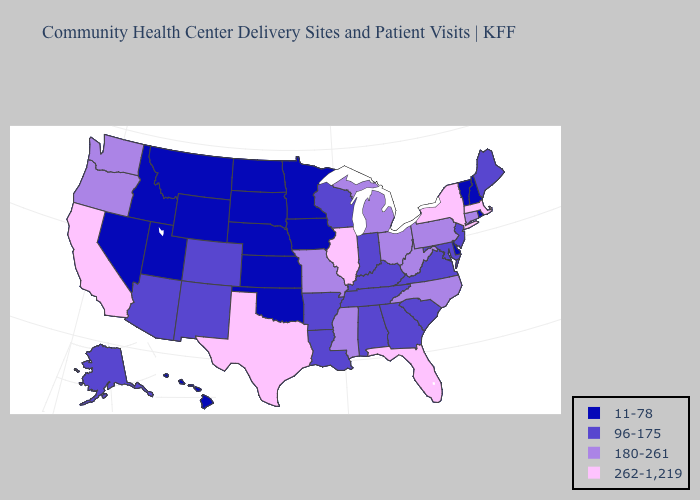Name the states that have a value in the range 96-175?
Keep it brief. Alabama, Alaska, Arizona, Arkansas, Colorado, Georgia, Indiana, Kentucky, Louisiana, Maine, Maryland, New Jersey, New Mexico, South Carolina, Tennessee, Virginia, Wisconsin. What is the lowest value in the USA?
Be succinct. 11-78. Name the states that have a value in the range 180-261?
Give a very brief answer. Connecticut, Michigan, Mississippi, Missouri, North Carolina, Ohio, Oregon, Pennsylvania, Washington, West Virginia. What is the lowest value in states that border Alabama?
Answer briefly. 96-175. Name the states that have a value in the range 11-78?
Write a very short answer. Delaware, Hawaii, Idaho, Iowa, Kansas, Minnesota, Montana, Nebraska, Nevada, New Hampshire, North Dakota, Oklahoma, Rhode Island, South Dakota, Utah, Vermont, Wyoming. Which states have the highest value in the USA?
Keep it brief. California, Florida, Illinois, Massachusetts, New York, Texas. What is the value of Kansas?
Write a very short answer. 11-78. Among the states that border Wisconsin , does Iowa have the highest value?
Answer briefly. No. What is the lowest value in the Northeast?
Keep it brief. 11-78. Does Hawaii have the highest value in the USA?
Answer briefly. No. Which states have the highest value in the USA?
Short answer required. California, Florida, Illinois, Massachusetts, New York, Texas. Does California have a higher value than Massachusetts?
Quick response, please. No. Name the states that have a value in the range 96-175?
Quick response, please. Alabama, Alaska, Arizona, Arkansas, Colorado, Georgia, Indiana, Kentucky, Louisiana, Maine, Maryland, New Jersey, New Mexico, South Carolina, Tennessee, Virginia, Wisconsin. Does Arizona have the same value as Iowa?
Concise answer only. No. Does Florida have a lower value than Washington?
Answer briefly. No. 